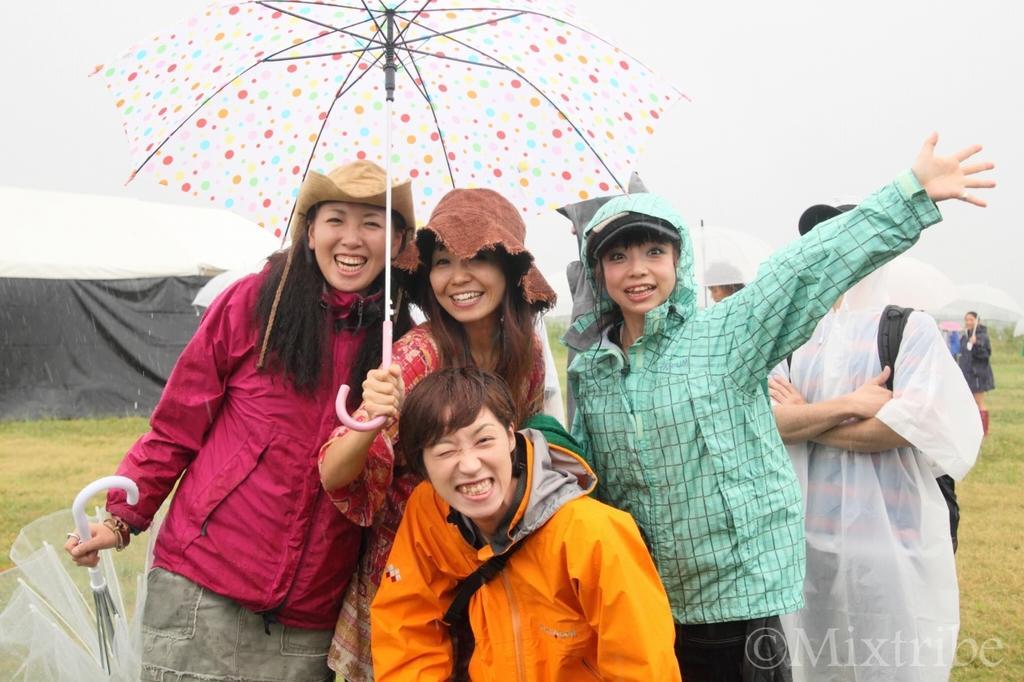Describe this image in one or two sentences. In the foreground of the picture there are people wearing raincoats. In the center there is a woman holding an umbrella. On the left there is a woman holding an umbrella. In the background there are people, grass and tent. Sky is cloudy. 